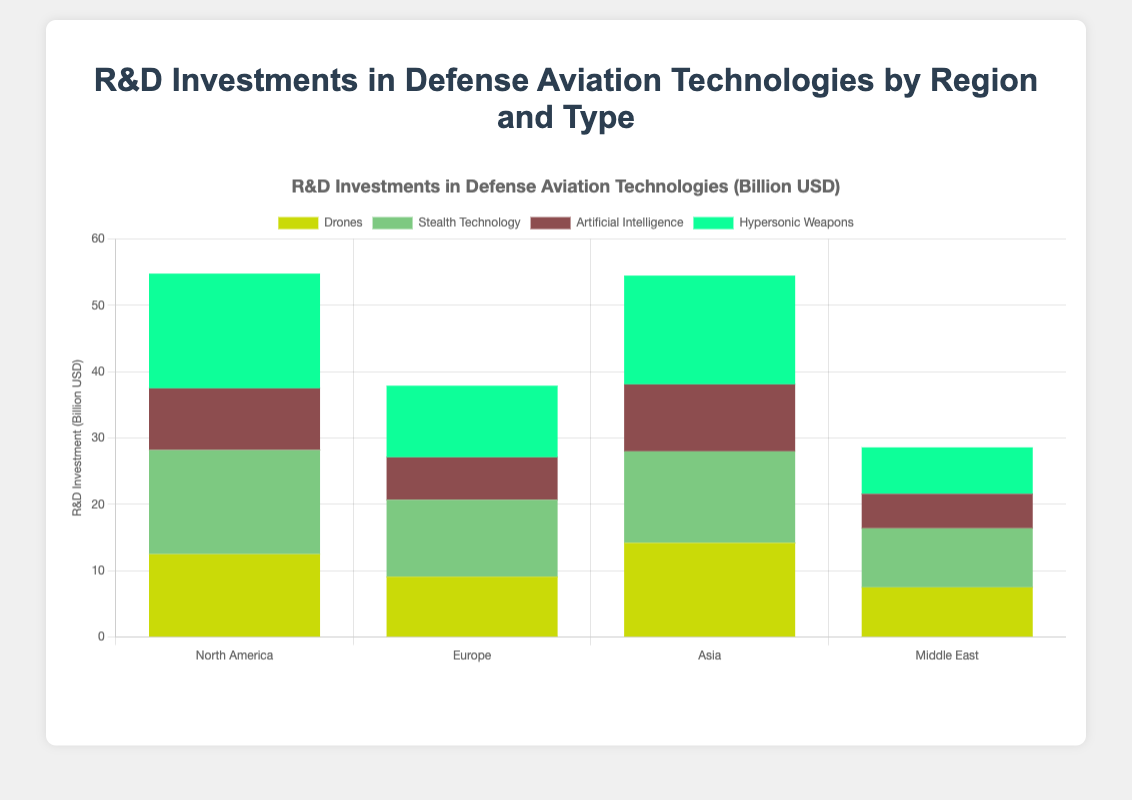Which region has the highest overall R&D investment in defense aviation technologies? By summing up the investments for each type in each region: North America (12.5 + 15.7 + 9.3 + 17.3 = 54.8), Europe (9.1 + 11.6 + 6.4 + 10.8 = 37.9), Asia (14.2 + 13.8 + 10.1 + 16.4 = 54.5), Middle East (7.5 + 8.9 + 5.2 + 7.0 = 28.6). North America has the highest at 54.8 billion USD.
Answer: North America Which region has the lowest investment in Artificial Intelligence? Check the investment in Artificial Intelligence for each region: North America (9.3), Europe (6.4), Asia (10.1), Middle East (5.2). The Middle East has the lowest investment in Artificial Intelligence with 5.2 billion USD.
Answer: Middle East Which defense aviation technology type has the highest combined investment across all regions? Sum the investments for each type across all regions: Drones (12.5 + 9.1 + 14.2 + 7.5 = 43.3), Stealth Technology (15.7 + 11.6 + 13.8 + 8.9 = 50.0), Artificial Intelligence (9.3 + 6.4 + 10.1 + 5.2 = 31.0), Hypersonic Weapons (17.3 + 10.8 + 16.4 + 7.0 = 51.5). Hypersonic Weapons has the highest combined investment at 51.5 billion USD.
Answer: Hypersonic Weapons In which technology type does Europe invest the most? By looking at the individual investments in each type within Europe: Drones (9.1), Stealth Technology (11.6), Artificial Intelligence (6.4), Hypersonic Weapons (10.8). Stealth Technology has the highest investment at 11.6 billion USD.
Answer: Stealth Technology How does the investment in Hypersonic Weapons in North America compare to Asia? Compare the investments in Hypersonic Weapons for North America (17.3) and Asia (16.4). North America's investment of 17.3 billion USD is higher than Asia's 16.4 billion USD.
Answer: North America invests more What is the percentage contribution of Drones to total R&D investment in the Middle East? Total R&D investment in the Middle East is (7.5 + 8.9 + 5.2 + 7.0 = 28.6). Drones investment is 7.5. The percentage is (7.5 / 28.6) * 100 ≈ 26.2%.
Answer: 26.2% Which company is responsible for the investment in Artificial Intelligence in the Middle East? Reference the datasets: Elbit Systems is the entity listed for Artificial Intelligence in the Middle East with an investment of 5.2 billion USD.
Answer: Elbit Systems Between Europe and Asia, which region invests more in Stealth Technology and by how much? Europe's investment in Stealth Technology is 11.6, and Asia's is 13.8. Asia invests 13.8 - 11.6 = 2.2 billion USD more than Europe.
Answer: Asia by 2.2 billion USD What is the total investment in Stealth Technology across all regions? Sum the investments in Stealth Technology from all regions: North America (15.7), Europe (11.6), Asia (13.8), Middle East (8.9). The total is (15.7 + 11.6 + 13.8 + 8.9 = 50.0).
Answer: 50.0 billion USD Which region has the highest investment in Drones, and what is the amount? Compare the investments in Drones among the regions: North America (12.5), Europe (9.1), Asia (14.2), Middle East (7.5). Asia has the highest investment in Drones with 14.2 billion USD.
Answer: Asia, 14.2 billion USD 